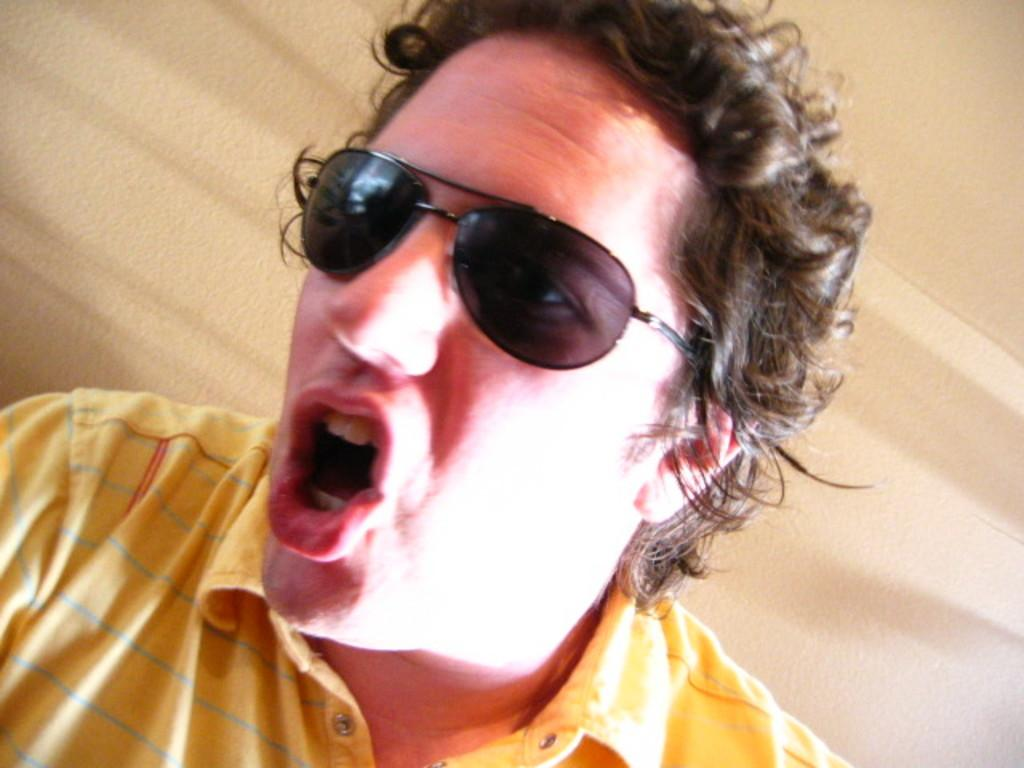What is the main subject of the image? There is a person in the image. What is the person wearing on their upper body? The person is wearing a yellow T-shirt. What accessory is the person wearing? The person is wearing glasses. What is the person doing with their mouth? The person has opened their mouth. What can be seen in the background of the image? There is a wall in the background of the image. What color is the wall? The wall is in cream color. What type of gold jewelry is the person wearing in the image? There is no gold jewelry visible in the image. What type of flesh can be seen on the person's face in the image? The image does not provide a detailed view of the person's face, so it is not possible to determine the type of flesh visible. 